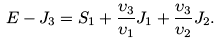<formula> <loc_0><loc_0><loc_500><loc_500>E - J _ { 3 } = S _ { 1 } + \frac { \upsilon _ { 3 } } { \upsilon _ { 1 } } J _ { 1 } + \frac { \upsilon _ { 3 } } { \upsilon _ { 2 } } J _ { 2 } .</formula> 